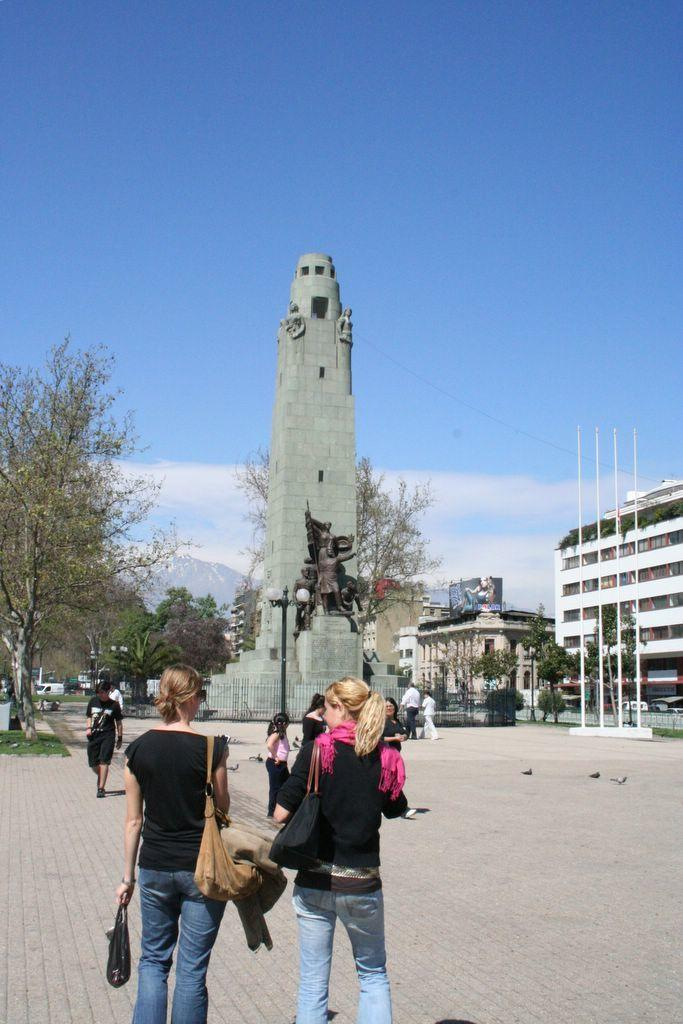What is located in the foreground of the image? There are people in the foreground of the image. What can be seen on a headstone in the image? There is a statue on a headstone in the image. What structures are visible in the background of the image? There is a tower, poles, trees, and buildings in the background of the image. What part of the natural environment is visible in the image? The sky is visible in the background of the image. Can you see any worms crawling on the statue in the image? There are no worms visible in the image, as it features a statue on a headstone and worms are not mentioned in the provided facts. What type of coast can be seen in the background of the image? There is no coast visible in the image; it features a tower, poles, trees, buildings, and the sky in the background. 